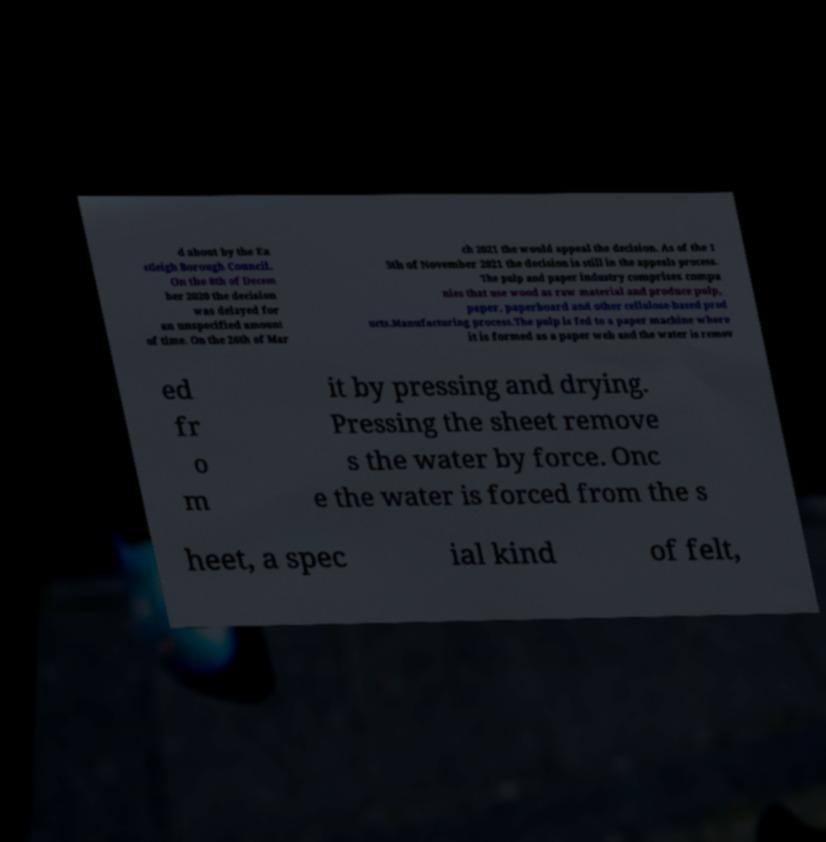I need the written content from this picture converted into text. Can you do that? d about by the Ea stleigh Borough Council. On the 8th of Decem ber 2020 the decision was delayed for an unspecified amount of time. On the 26th of Mar ch 2021 the would appeal the decision. As of the 1 3th of November 2021 the decision is still in the appeals process. The pulp and paper industry comprises compa nies that use wood as raw material and produce pulp, paper, paperboard and other cellulose-based prod ucts.Manufacturing process.The pulp is fed to a paper machine where it is formed as a paper web and the water is remov ed fr o m it by pressing and drying. Pressing the sheet remove s the water by force. Onc e the water is forced from the s heet, a spec ial kind of felt, 